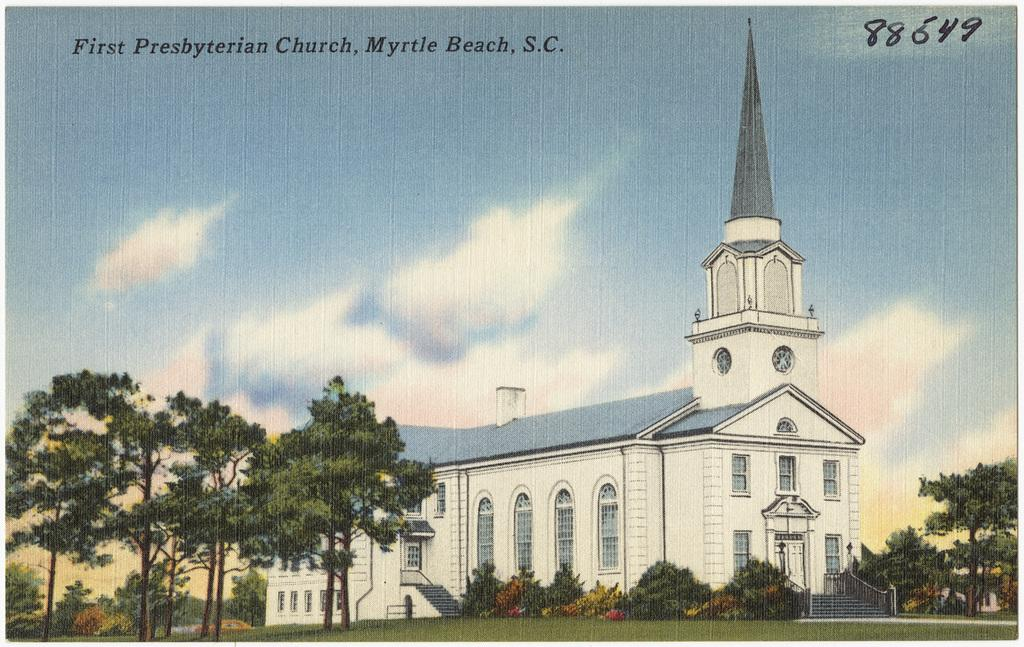What type of vegetation can be seen in the image? There are trees, grass, and plants in the image. What type of structure is present in the image? There is a building in the image. What architectural feature can be seen in the image? There is a staircase in the image. What is visible in the sky in the image? The sky is visible in the image. What type of image is it? The image appears to be an edited photo. How many pies are being served on the staircase in the image? There are no pies present in the image. What type of idea is being expressed through the text in the image? There is no text in the image that expresses an idea. 